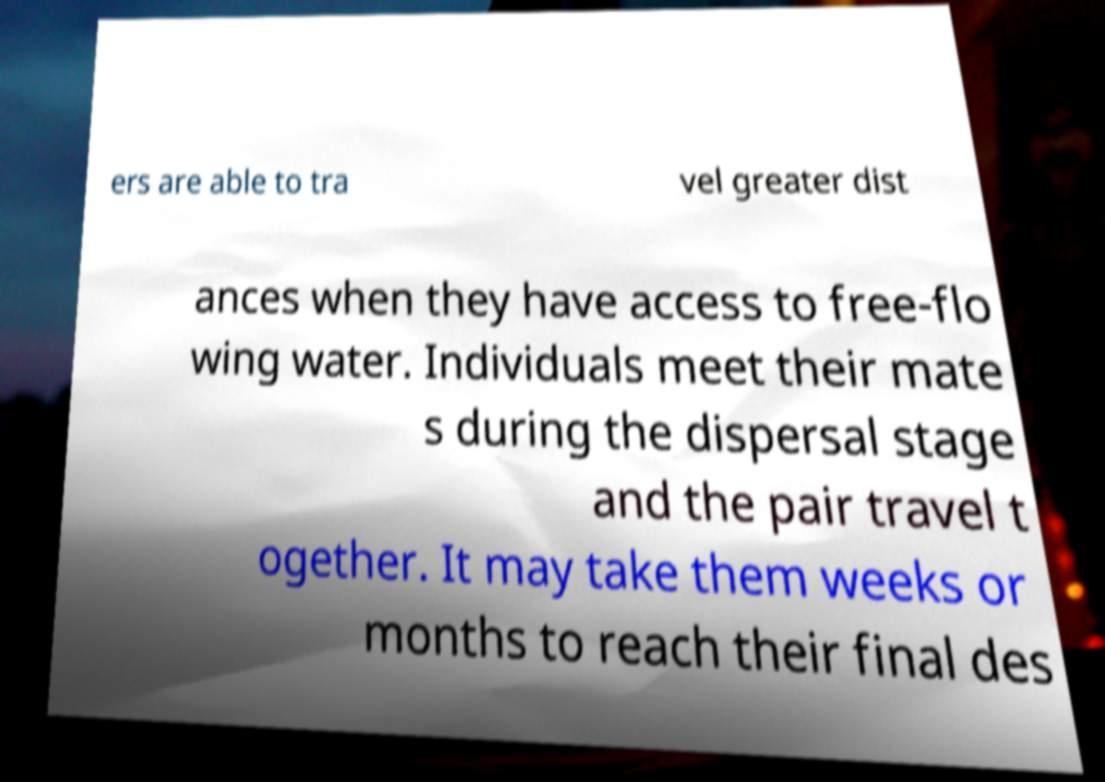For documentation purposes, I need the text within this image transcribed. Could you provide that? ers are able to tra vel greater dist ances when they have access to free-flo wing water. Individuals meet their mate s during the dispersal stage and the pair travel t ogether. It may take them weeks or months to reach their final des 